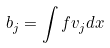Convert formula to latex. <formula><loc_0><loc_0><loc_500><loc_500>b _ { j } = \int f v _ { j } d x</formula> 